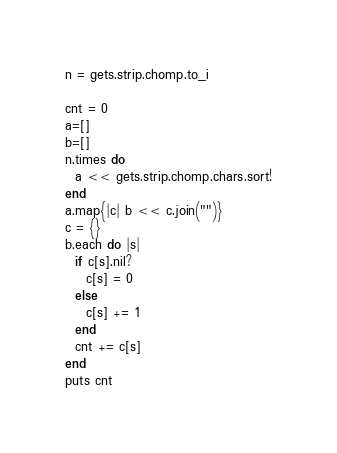Convert code to text. <code><loc_0><loc_0><loc_500><loc_500><_Ruby_>n = gets.strip.chomp.to_i

cnt = 0
a=[]
b=[]
n.times do
  a << gets.strip.chomp.chars.sort!
end
a.map{|c| b << c.join("")}
c = {}
b.each do |s|
  if c[s].nil?
    c[s] = 0 
  else
    c[s] += 1
  end
  cnt += c[s]
end
puts cnt</code> 